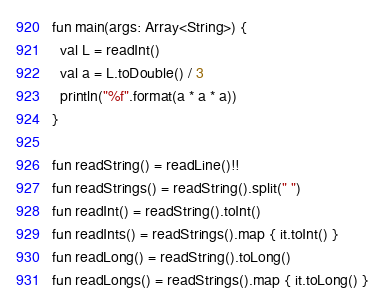Convert code to text. <code><loc_0><loc_0><loc_500><loc_500><_Kotlin_>fun main(args: Array<String>) {
  val L = readInt()
  val a = L.toDouble() / 3
  println("%f".format(a * a * a))
}

fun readString() = readLine()!!
fun readStrings() = readString().split(" ")
fun readInt() = readString().toInt()
fun readInts() = readStrings().map { it.toInt() }
fun readLong() = readString().toLong()
fun readLongs() = readStrings().map { it.toLong() }
</code> 